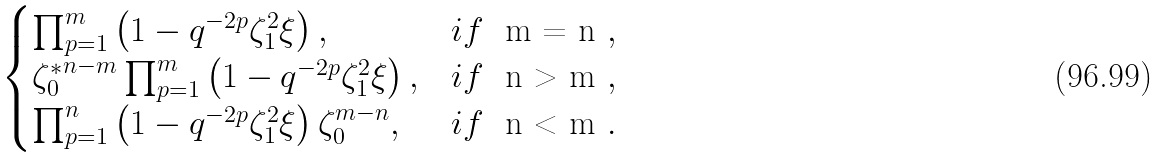Convert formula to latex. <formula><loc_0><loc_0><loc_500><loc_500>\begin{cases} \prod _ { p = 1 } ^ { m } \left ( 1 - q ^ { - 2 p } \zeta _ { 1 } ^ { 2 } \xi \right ) , & i f \ $ m = n $ , \\ { \zeta _ { 0 } ^ { * } } ^ { n - m } \prod _ { p = 1 } ^ { m } \left ( 1 - q ^ { - 2 p } \zeta _ { 1 } ^ { 2 } \xi \right ) , & i f \ $ n > m $ , \\ \prod _ { p = 1 } ^ { n } \left ( 1 - q ^ { - 2 p } \zeta _ { 1 } ^ { 2 } \xi \right ) \zeta _ { 0 } ^ { m - n } , & i f \ $ n < m $ . \end{cases}</formula> 